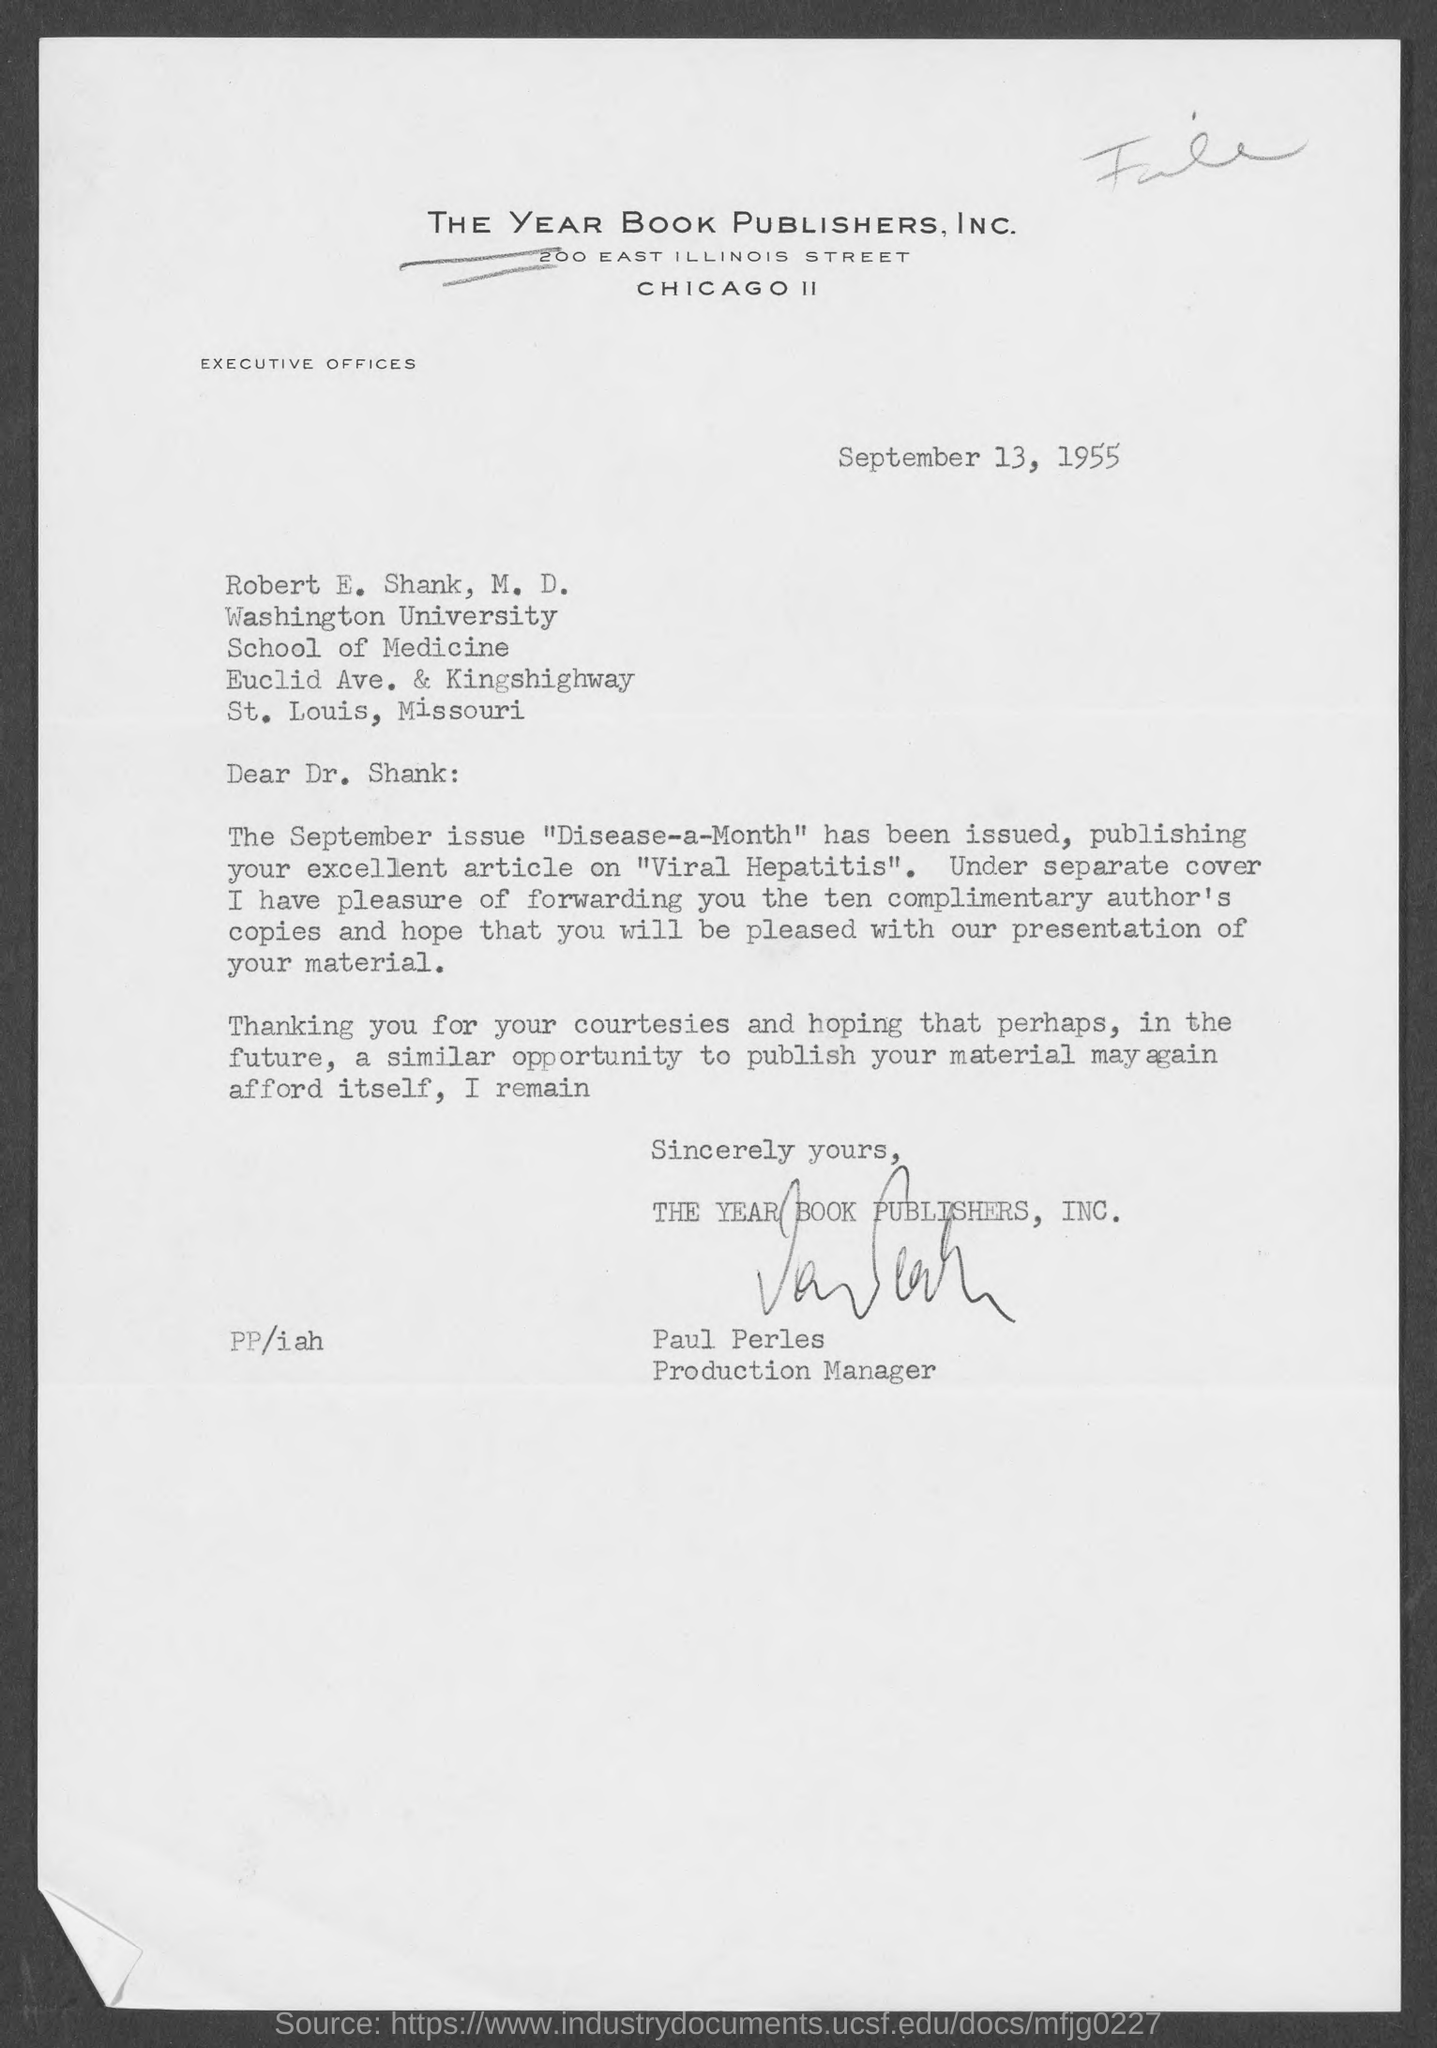Indicate a few pertinent items in this graphic. The date mentioned at the top of the document is September 13, 1955. The Company Name is THE YEAR BOOK PUBLISHERS, INC., located in [City, State] 